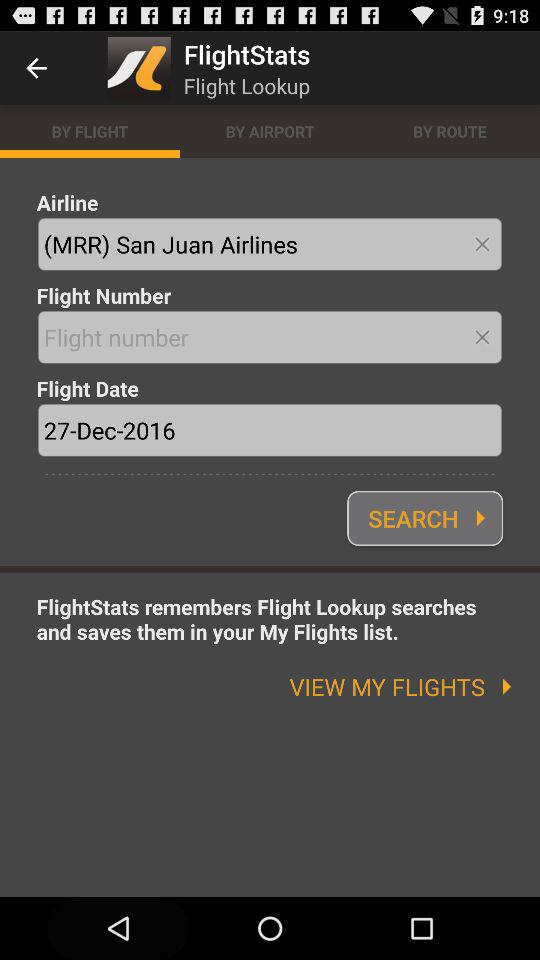What is the application name? The application name is "FlightStats". 